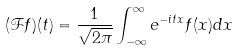Convert formula to latex. <formula><loc_0><loc_0><loc_500><loc_500>( \mathcal { F } f ) ( t ) = \frac { 1 } { \sqrt { 2 \pi } } \int _ { - \infty } ^ { \infty } e ^ { - i t x } f ( x ) d x</formula> 